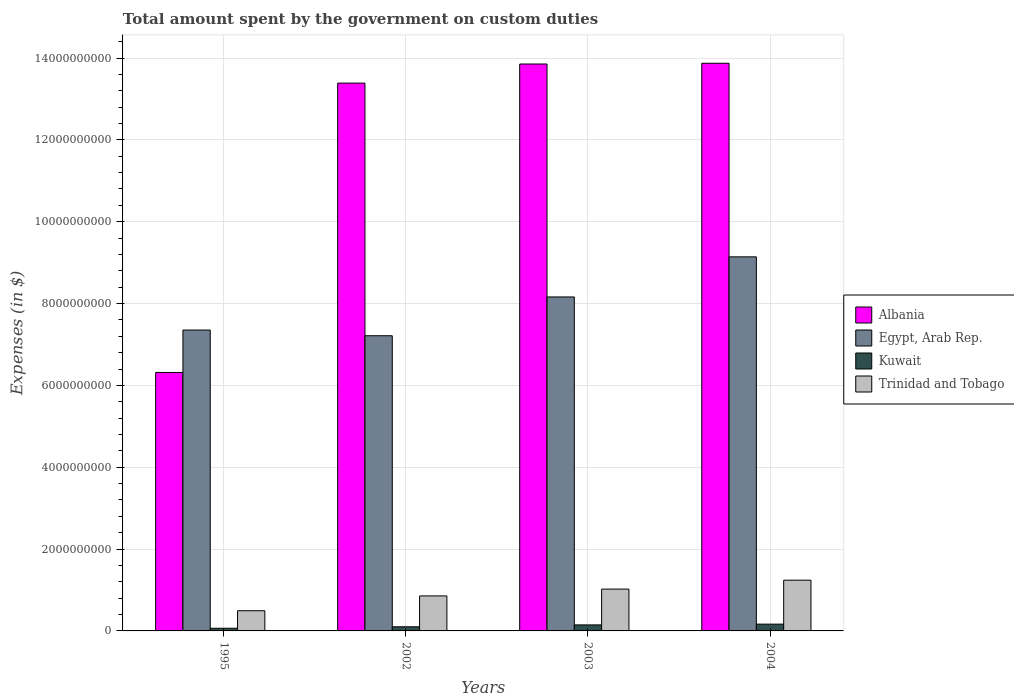How many groups of bars are there?
Your answer should be very brief. 4. Are the number of bars per tick equal to the number of legend labels?
Give a very brief answer. Yes. How many bars are there on the 4th tick from the left?
Your response must be concise. 4. How many bars are there on the 4th tick from the right?
Ensure brevity in your answer.  4. What is the label of the 4th group of bars from the left?
Your answer should be compact. 2004. In how many cases, is the number of bars for a given year not equal to the number of legend labels?
Provide a short and direct response. 0. What is the amount spent on custom duties by the government in Egypt, Arab Rep. in 1995?
Your response must be concise. 7.35e+09. Across all years, what is the maximum amount spent on custom duties by the government in Trinidad and Tobago?
Your answer should be very brief. 1.24e+09. Across all years, what is the minimum amount spent on custom duties by the government in Kuwait?
Provide a succinct answer. 6.50e+07. What is the total amount spent on custom duties by the government in Kuwait in the graph?
Provide a succinct answer. 4.79e+08. What is the difference between the amount spent on custom duties by the government in Kuwait in 2003 and that in 2004?
Your answer should be very brief. -1.90e+07. What is the difference between the amount spent on custom duties by the government in Albania in 2003 and the amount spent on custom duties by the government in Kuwait in 2002?
Provide a short and direct response. 1.38e+1. What is the average amount spent on custom duties by the government in Albania per year?
Offer a terse response. 1.19e+1. In the year 2003, what is the difference between the amount spent on custom duties by the government in Kuwait and amount spent on custom duties by the government in Albania?
Keep it short and to the point. -1.37e+1. In how many years, is the amount spent on custom duties by the government in Kuwait greater than 12400000000 $?
Provide a succinct answer. 0. What is the ratio of the amount spent on custom duties by the government in Albania in 2002 to that in 2004?
Offer a terse response. 0.97. What is the difference between the highest and the second highest amount spent on custom duties by the government in Trinidad and Tobago?
Your answer should be compact. 2.18e+08. What is the difference between the highest and the lowest amount spent on custom duties by the government in Kuwait?
Your answer should be very brief. 1.01e+08. Is the sum of the amount spent on custom duties by the government in Kuwait in 2002 and 2003 greater than the maximum amount spent on custom duties by the government in Egypt, Arab Rep. across all years?
Offer a terse response. No. Is it the case that in every year, the sum of the amount spent on custom duties by the government in Egypt, Arab Rep. and amount spent on custom duties by the government in Kuwait is greater than the sum of amount spent on custom duties by the government in Trinidad and Tobago and amount spent on custom duties by the government in Albania?
Give a very brief answer. No. What does the 4th bar from the left in 2002 represents?
Offer a very short reply. Trinidad and Tobago. What does the 1st bar from the right in 1995 represents?
Your response must be concise. Trinidad and Tobago. How many bars are there?
Keep it short and to the point. 16. How many years are there in the graph?
Provide a succinct answer. 4. Does the graph contain any zero values?
Your answer should be very brief. No. Where does the legend appear in the graph?
Ensure brevity in your answer.  Center right. How are the legend labels stacked?
Make the answer very short. Vertical. What is the title of the graph?
Provide a succinct answer. Total amount spent by the government on custom duties. Does "Uruguay" appear as one of the legend labels in the graph?
Provide a short and direct response. No. What is the label or title of the X-axis?
Provide a short and direct response. Years. What is the label or title of the Y-axis?
Keep it short and to the point. Expenses (in $). What is the Expenses (in $) of Albania in 1995?
Offer a very short reply. 6.32e+09. What is the Expenses (in $) of Egypt, Arab Rep. in 1995?
Provide a short and direct response. 7.35e+09. What is the Expenses (in $) of Kuwait in 1995?
Keep it short and to the point. 6.50e+07. What is the Expenses (in $) in Trinidad and Tobago in 1995?
Your response must be concise. 4.94e+08. What is the Expenses (in $) of Albania in 2002?
Provide a succinct answer. 1.34e+1. What is the Expenses (in $) of Egypt, Arab Rep. in 2002?
Offer a very short reply. 7.21e+09. What is the Expenses (in $) of Kuwait in 2002?
Provide a short and direct response. 1.01e+08. What is the Expenses (in $) in Trinidad and Tobago in 2002?
Offer a terse response. 8.55e+08. What is the Expenses (in $) in Albania in 2003?
Your answer should be very brief. 1.39e+1. What is the Expenses (in $) in Egypt, Arab Rep. in 2003?
Your answer should be compact. 8.16e+09. What is the Expenses (in $) in Kuwait in 2003?
Offer a very short reply. 1.47e+08. What is the Expenses (in $) of Trinidad and Tobago in 2003?
Your response must be concise. 1.02e+09. What is the Expenses (in $) of Albania in 2004?
Make the answer very short. 1.39e+1. What is the Expenses (in $) of Egypt, Arab Rep. in 2004?
Keep it short and to the point. 9.14e+09. What is the Expenses (in $) of Kuwait in 2004?
Offer a very short reply. 1.66e+08. What is the Expenses (in $) in Trinidad and Tobago in 2004?
Your answer should be compact. 1.24e+09. Across all years, what is the maximum Expenses (in $) in Albania?
Offer a very short reply. 1.39e+1. Across all years, what is the maximum Expenses (in $) in Egypt, Arab Rep.?
Ensure brevity in your answer.  9.14e+09. Across all years, what is the maximum Expenses (in $) in Kuwait?
Provide a short and direct response. 1.66e+08. Across all years, what is the maximum Expenses (in $) of Trinidad and Tobago?
Offer a very short reply. 1.24e+09. Across all years, what is the minimum Expenses (in $) in Albania?
Your answer should be compact. 6.32e+09. Across all years, what is the minimum Expenses (in $) in Egypt, Arab Rep.?
Make the answer very short. 7.21e+09. Across all years, what is the minimum Expenses (in $) in Kuwait?
Make the answer very short. 6.50e+07. Across all years, what is the minimum Expenses (in $) of Trinidad and Tobago?
Keep it short and to the point. 4.94e+08. What is the total Expenses (in $) of Albania in the graph?
Ensure brevity in your answer.  4.74e+1. What is the total Expenses (in $) of Egypt, Arab Rep. in the graph?
Provide a succinct answer. 3.19e+1. What is the total Expenses (in $) in Kuwait in the graph?
Your answer should be compact. 4.79e+08. What is the total Expenses (in $) in Trinidad and Tobago in the graph?
Your answer should be compact. 3.61e+09. What is the difference between the Expenses (in $) of Albania in 1995 and that in 2002?
Give a very brief answer. -7.07e+09. What is the difference between the Expenses (in $) in Egypt, Arab Rep. in 1995 and that in 2002?
Provide a short and direct response. 1.39e+08. What is the difference between the Expenses (in $) of Kuwait in 1995 and that in 2002?
Your answer should be very brief. -3.60e+07. What is the difference between the Expenses (in $) in Trinidad and Tobago in 1995 and that in 2002?
Provide a short and direct response. -3.62e+08. What is the difference between the Expenses (in $) in Albania in 1995 and that in 2003?
Ensure brevity in your answer.  -7.54e+09. What is the difference between the Expenses (in $) of Egypt, Arab Rep. in 1995 and that in 2003?
Your answer should be very brief. -8.09e+08. What is the difference between the Expenses (in $) of Kuwait in 1995 and that in 2003?
Your answer should be compact. -8.20e+07. What is the difference between the Expenses (in $) in Trinidad and Tobago in 1995 and that in 2003?
Offer a very short reply. -5.29e+08. What is the difference between the Expenses (in $) of Albania in 1995 and that in 2004?
Give a very brief answer. -7.56e+09. What is the difference between the Expenses (in $) of Egypt, Arab Rep. in 1995 and that in 2004?
Offer a terse response. -1.79e+09. What is the difference between the Expenses (in $) of Kuwait in 1995 and that in 2004?
Offer a terse response. -1.01e+08. What is the difference between the Expenses (in $) of Trinidad and Tobago in 1995 and that in 2004?
Keep it short and to the point. -7.46e+08. What is the difference between the Expenses (in $) of Albania in 2002 and that in 2003?
Give a very brief answer. -4.67e+08. What is the difference between the Expenses (in $) in Egypt, Arab Rep. in 2002 and that in 2003?
Ensure brevity in your answer.  -9.48e+08. What is the difference between the Expenses (in $) of Kuwait in 2002 and that in 2003?
Make the answer very short. -4.60e+07. What is the difference between the Expenses (in $) in Trinidad and Tobago in 2002 and that in 2003?
Keep it short and to the point. -1.67e+08. What is the difference between the Expenses (in $) in Albania in 2002 and that in 2004?
Your answer should be very brief. -4.85e+08. What is the difference between the Expenses (in $) of Egypt, Arab Rep. in 2002 and that in 2004?
Your answer should be compact. -1.93e+09. What is the difference between the Expenses (in $) in Kuwait in 2002 and that in 2004?
Ensure brevity in your answer.  -6.50e+07. What is the difference between the Expenses (in $) of Trinidad and Tobago in 2002 and that in 2004?
Your answer should be compact. -3.84e+08. What is the difference between the Expenses (in $) in Albania in 2003 and that in 2004?
Your answer should be compact. -1.81e+07. What is the difference between the Expenses (in $) in Egypt, Arab Rep. in 2003 and that in 2004?
Provide a short and direct response. -9.80e+08. What is the difference between the Expenses (in $) of Kuwait in 2003 and that in 2004?
Give a very brief answer. -1.90e+07. What is the difference between the Expenses (in $) of Trinidad and Tobago in 2003 and that in 2004?
Make the answer very short. -2.18e+08. What is the difference between the Expenses (in $) in Albania in 1995 and the Expenses (in $) in Egypt, Arab Rep. in 2002?
Offer a very short reply. -8.97e+08. What is the difference between the Expenses (in $) in Albania in 1995 and the Expenses (in $) in Kuwait in 2002?
Your answer should be very brief. 6.22e+09. What is the difference between the Expenses (in $) of Albania in 1995 and the Expenses (in $) of Trinidad and Tobago in 2002?
Make the answer very short. 5.46e+09. What is the difference between the Expenses (in $) of Egypt, Arab Rep. in 1995 and the Expenses (in $) of Kuwait in 2002?
Your answer should be compact. 7.25e+09. What is the difference between the Expenses (in $) in Egypt, Arab Rep. in 1995 and the Expenses (in $) in Trinidad and Tobago in 2002?
Make the answer very short. 6.50e+09. What is the difference between the Expenses (in $) of Kuwait in 1995 and the Expenses (in $) of Trinidad and Tobago in 2002?
Provide a short and direct response. -7.90e+08. What is the difference between the Expenses (in $) of Albania in 1995 and the Expenses (in $) of Egypt, Arab Rep. in 2003?
Your answer should be very brief. -1.84e+09. What is the difference between the Expenses (in $) of Albania in 1995 and the Expenses (in $) of Kuwait in 2003?
Ensure brevity in your answer.  6.17e+09. What is the difference between the Expenses (in $) of Albania in 1995 and the Expenses (in $) of Trinidad and Tobago in 2003?
Make the answer very short. 5.29e+09. What is the difference between the Expenses (in $) of Egypt, Arab Rep. in 1995 and the Expenses (in $) of Kuwait in 2003?
Your answer should be very brief. 7.20e+09. What is the difference between the Expenses (in $) in Egypt, Arab Rep. in 1995 and the Expenses (in $) in Trinidad and Tobago in 2003?
Keep it short and to the point. 6.33e+09. What is the difference between the Expenses (in $) of Kuwait in 1995 and the Expenses (in $) of Trinidad and Tobago in 2003?
Keep it short and to the point. -9.57e+08. What is the difference between the Expenses (in $) of Albania in 1995 and the Expenses (in $) of Egypt, Arab Rep. in 2004?
Provide a short and direct response. -2.82e+09. What is the difference between the Expenses (in $) of Albania in 1995 and the Expenses (in $) of Kuwait in 2004?
Give a very brief answer. 6.15e+09. What is the difference between the Expenses (in $) of Albania in 1995 and the Expenses (in $) of Trinidad and Tobago in 2004?
Provide a short and direct response. 5.08e+09. What is the difference between the Expenses (in $) of Egypt, Arab Rep. in 1995 and the Expenses (in $) of Kuwait in 2004?
Keep it short and to the point. 7.19e+09. What is the difference between the Expenses (in $) in Egypt, Arab Rep. in 1995 and the Expenses (in $) in Trinidad and Tobago in 2004?
Give a very brief answer. 6.11e+09. What is the difference between the Expenses (in $) in Kuwait in 1995 and the Expenses (in $) in Trinidad and Tobago in 2004?
Your response must be concise. -1.17e+09. What is the difference between the Expenses (in $) of Albania in 2002 and the Expenses (in $) of Egypt, Arab Rep. in 2003?
Offer a very short reply. 5.23e+09. What is the difference between the Expenses (in $) of Albania in 2002 and the Expenses (in $) of Kuwait in 2003?
Provide a succinct answer. 1.32e+1. What is the difference between the Expenses (in $) of Albania in 2002 and the Expenses (in $) of Trinidad and Tobago in 2003?
Ensure brevity in your answer.  1.24e+1. What is the difference between the Expenses (in $) of Egypt, Arab Rep. in 2002 and the Expenses (in $) of Kuwait in 2003?
Your answer should be very brief. 7.07e+09. What is the difference between the Expenses (in $) of Egypt, Arab Rep. in 2002 and the Expenses (in $) of Trinidad and Tobago in 2003?
Provide a succinct answer. 6.19e+09. What is the difference between the Expenses (in $) of Kuwait in 2002 and the Expenses (in $) of Trinidad and Tobago in 2003?
Offer a terse response. -9.21e+08. What is the difference between the Expenses (in $) of Albania in 2002 and the Expenses (in $) of Egypt, Arab Rep. in 2004?
Your response must be concise. 4.25e+09. What is the difference between the Expenses (in $) of Albania in 2002 and the Expenses (in $) of Kuwait in 2004?
Your response must be concise. 1.32e+1. What is the difference between the Expenses (in $) in Albania in 2002 and the Expenses (in $) in Trinidad and Tobago in 2004?
Make the answer very short. 1.21e+1. What is the difference between the Expenses (in $) in Egypt, Arab Rep. in 2002 and the Expenses (in $) in Kuwait in 2004?
Keep it short and to the point. 7.05e+09. What is the difference between the Expenses (in $) in Egypt, Arab Rep. in 2002 and the Expenses (in $) in Trinidad and Tobago in 2004?
Offer a terse response. 5.97e+09. What is the difference between the Expenses (in $) of Kuwait in 2002 and the Expenses (in $) of Trinidad and Tobago in 2004?
Give a very brief answer. -1.14e+09. What is the difference between the Expenses (in $) in Albania in 2003 and the Expenses (in $) in Egypt, Arab Rep. in 2004?
Make the answer very short. 4.71e+09. What is the difference between the Expenses (in $) in Albania in 2003 and the Expenses (in $) in Kuwait in 2004?
Keep it short and to the point. 1.37e+1. What is the difference between the Expenses (in $) of Albania in 2003 and the Expenses (in $) of Trinidad and Tobago in 2004?
Provide a succinct answer. 1.26e+1. What is the difference between the Expenses (in $) in Egypt, Arab Rep. in 2003 and the Expenses (in $) in Kuwait in 2004?
Offer a terse response. 8.00e+09. What is the difference between the Expenses (in $) of Egypt, Arab Rep. in 2003 and the Expenses (in $) of Trinidad and Tobago in 2004?
Provide a short and direct response. 6.92e+09. What is the difference between the Expenses (in $) of Kuwait in 2003 and the Expenses (in $) of Trinidad and Tobago in 2004?
Your answer should be very brief. -1.09e+09. What is the average Expenses (in $) of Albania per year?
Your answer should be compact. 1.19e+1. What is the average Expenses (in $) of Egypt, Arab Rep. per year?
Your response must be concise. 7.97e+09. What is the average Expenses (in $) in Kuwait per year?
Provide a short and direct response. 1.20e+08. What is the average Expenses (in $) in Trinidad and Tobago per year?
Your answer should be compact. 9.03e+08. In the year 1995, what is the difference between the Expenses (in $) of Albania and Expenses (in $) of Egypt, Arab Rep.?
Your response must be concise. -1.04e+09. In the year 1995, what is the difference between the Expenses (in $) of Albania and Expenses (in $) of Kuwait?
Make the answer very short. 6.25e+09. In the year 1995, what is the difference between the Expenses (in $) of Albania and Expenses (in $) of Trinidad and Tobago?
Your answer should be compact. 5.82e+09. In the year 1995, what is the difference between the Expenses (in $) of Egypt, Arab Rep. and Expenses (in $) of Kuwait?
Provide a succinct answer. 7.29e+09. In the year 1995, what is the difference between the Expenses (in $) of Egypt, Arab Rep. and Expenses (in $) of Trinidad and Tobago?
Provide a short and direct response. 6.86e+09. In the year 1995, what is the difference between the Expenses (in $) in Kuwait and Expenses (in $) in Trinidad and Tobago?
Your answer should be very brief. -4.29e+08. In the year 2002, what is the difference between the Expenses (in $) in Albania and Expenses (in $) in Egypt, Arab Rep.?
Offer a terse response. 6.17e+09. In the year 2002, what is the difference between the Expenses (in $) of Albania and Expenses (in $) of Kuwait?
Make the answer very short. 1.33e+1. In the year 2002, what is the difference between the Expenses (in $) of Albania and Expenses (in $) of Trinidad and Tobago?
Offer a terse response. 1.25e+1. In the year 2002, what is the difference between the Expenses (in $) in Egypt, Arab Rep. and Expenses (in $) in Kuwait?
Provide a succinct answer. 7.11e+09. In the year 2002, what is the difference between the Expenses (in $) in Egypt, Arab Rep. and Expenses (in $) in Trinidad and Tobago?
Give a very brief answer. 6.36e+09. In the year 2002, what is the difference between the Expenses (in $) in Kuwait and Expenses (in $) in Trinidad and Tobago?
Ensure brevity in your answer.  -7.54e+08. In the year 2003, what is the difference between the Expenses (in $) in Albania and Expenses (in $) in Egypt, Arab Rep.?
Keep it short and to the point. 5.69e+09. In the year 2003, what is the difference between the Expenses (in $) in Albania and Expenses (in $) in Kuwait?
Provide a short and direct response. 1.37e+1. In the year 2003, what is the difference between the Expenses (in $) of Albania and Expenses (in $) of Trinidad and Tobago?
Offer a very short reply. 1.28e+1. In the year 2003, what is the difference between the Expenses (in $) of Egypt, Arab Rep. and Expenses (in $) of Kuwait?
Give a very brief answer. 8.01e+09. In the year 2003, what is the difference between the Expenses (in $) of Egypt, Arab Rep. and Expenses (in $) of Trinidad and Tobago?
Provide a short and direct response. 7.14e+09. In the year 2003, what is the difference between the Expenses (in $) of Kuwait and Expenses (in $) of Trinidad and Tobago?
Your answer should be compact. -8.75e+08. In the year 2004, what is the difference between the Expenses (in $) in Albania and Expenses (in $) in Egypt, Arab Rep.?
Ensure brevity in your answer.  4.73e+09. In the year 2004, what is the difference between the Expenses (in $) of Albania and Expenses (in $) of Kuwait?
Provide a succinct answer. 1.37e+1. In the year 2004, what is the difference between the Expenses (in $) in Albania and Expenses (in $) in Trinidad and Tobago?
Give a very brief answer. 1.26e+1. In the year 2004, what is the difference between the Expenses (in $) in Egypt, Arab Rep. and Expenses (in $) in Kuwait?
Provide a succinct answer. 8.98e+09. In the year 2004, what is the difference between the Expenses (in $) in Egypt, Arab Rep. and Expenses (in $) in Trinidad and Tobago?
Keep it short and to the point. 7.90e+09. In the year 2004, what is the difference between the Expenses (in $) of Kuwait and Expenses (in $) of Trinidad and Tobago?
Provide a short and direct response. -1.07e+09. What is the ratio of the Expenses (in $) of Albania in 1995 to that in 2002?
Provide a short and direct response. 0.47. What is the ratio of the Expenses (in $) of Egypt, Arab Rep. in 1995 to that in 2002?
Your response must be concise. 1.02. What is the ratio of the Expenses (in $) of Kuwait in 1995 to that in 2002?
Your response must be concise. 0.64. What is the ratio of the Expenses (in $) in Trinidad and Tobago in 1995 to that in 2002?
Offer a very short reply. 0.58. What is the ratio of the Expenses (in $) in Albania in 1995 to that in 2003?
Your response must be concise. 0.46. What is the ratio of the Expenses (in $) of Egypt, Arab Rep. in 1995 to that in 2003?
Give a very brief answer. 0.9. What is the ratio of the Expenses (in $) of Kuwait in 1995 to that in 2003?
Your answer should be very brief. 0.44. What is the ratio of the Expenses (in $) of Trinidad and Tobago in 1995 to that in 2003?
Keep it short and to the point. 0.48. What is the ratio of the Expenses (in $) in Albania in 1995 to that in 2004?
Offer a terse response. 0.46. What is the ratio of the Expenses (in $) in Egypt, Arab Rep. in 1995 to that in 2004?
Your response must be concise. 0.8. What is the ratio of the Expenses (in $) in Kuwait in 1995 to that in 2004?
Your answer should be very brief. 0.39. What is the ratio of the Expenses (in $) of Trinidad and Tobago in 1995 to that in 2004?
Your response must be concise. 0.4. What is the ratio of the Expenses (in $) in Albania in 2002 to that in 2003?
Your answer should be very brief. 0.97. What is the ratio of the Expenses (in $) of Egypt, Arab Rep. in 2002 to that in 2003?
Your answer should be very brief. 0.88. What is the ratio of the Expenses (in $) of Kuwait in 2002 to that in 2003?
Keep it short and to the point. 0.69. What is the ratio of the Expenses (in $) in Trinidad and Tobago in 2002 to that in 2003?
Provide a short and direct response. 0.84. What is the ratio of the Expenses (in $) of Egypt, Arab Rep. in 2002 to that in 2004?
Provide a short and direct response. 0.79. What is the ratio of the Expenses (in $) in Kuwait in 2002 to that in 2004?
Offer a terse response. 0.61. What is the ratio of the Expenses (in $) in Trinidad and Tobago in 2002 to that in 2004?
Provide a short and direct response. 0.69. What is the ratio of the Expenses (in $) in Albania in 2003 to that in 2004?
Make the answer very short. 1. What is the ratio of the Expenses (in $) of Egypt, Arab Rep. in 2003 to that in 2004?
Your answer should be compact. 0.89. What is the ratio of the Expenses (in $) of Kuwait in 2003 to that in 2004?
Offer a terse response. 0.89. What is the ratio of the Expenses (in $) of Trinidad and Tobago in 2003 to that in 2004?
Provide a short and direct response. 0.82. What is the difference between the highest and the second highest Expenses (in $) in Albania?
Provide a succinct answer. 1.81e+07. What is the difference between the highest and the second highest Expenses (in $) in Egypt, Arab Rep.?
Make the answer very short. 9.80e+08. What is the difference between the highest and the second highest Expenses (in $) in Kuwait?
Your response must be concise. 1.90e+07. What is the difference between the highest and the second highest Expenses (in $) of Trinidad and Tobago?
Provide a short and direct response. 2.18e+08. What is the difference between the highest and the lowest Expenses (in $) of Albania?
Provide a short and direct response. 7.56e+09. What is the difference between the highest and the lowest Expenses (in $) of Egypt, Arab Rep.?
Provide a succinct answer. 1.93e+09. What is the difference between the highest and the lowest Expenses (in $) of Kuwait?
Provide a short and direct response. 1.01e+08. What is the difference between the highest and the lowest Expenses (in $) in Trinidad and Tobago?
Your response must be concise. 7.46e+08. 